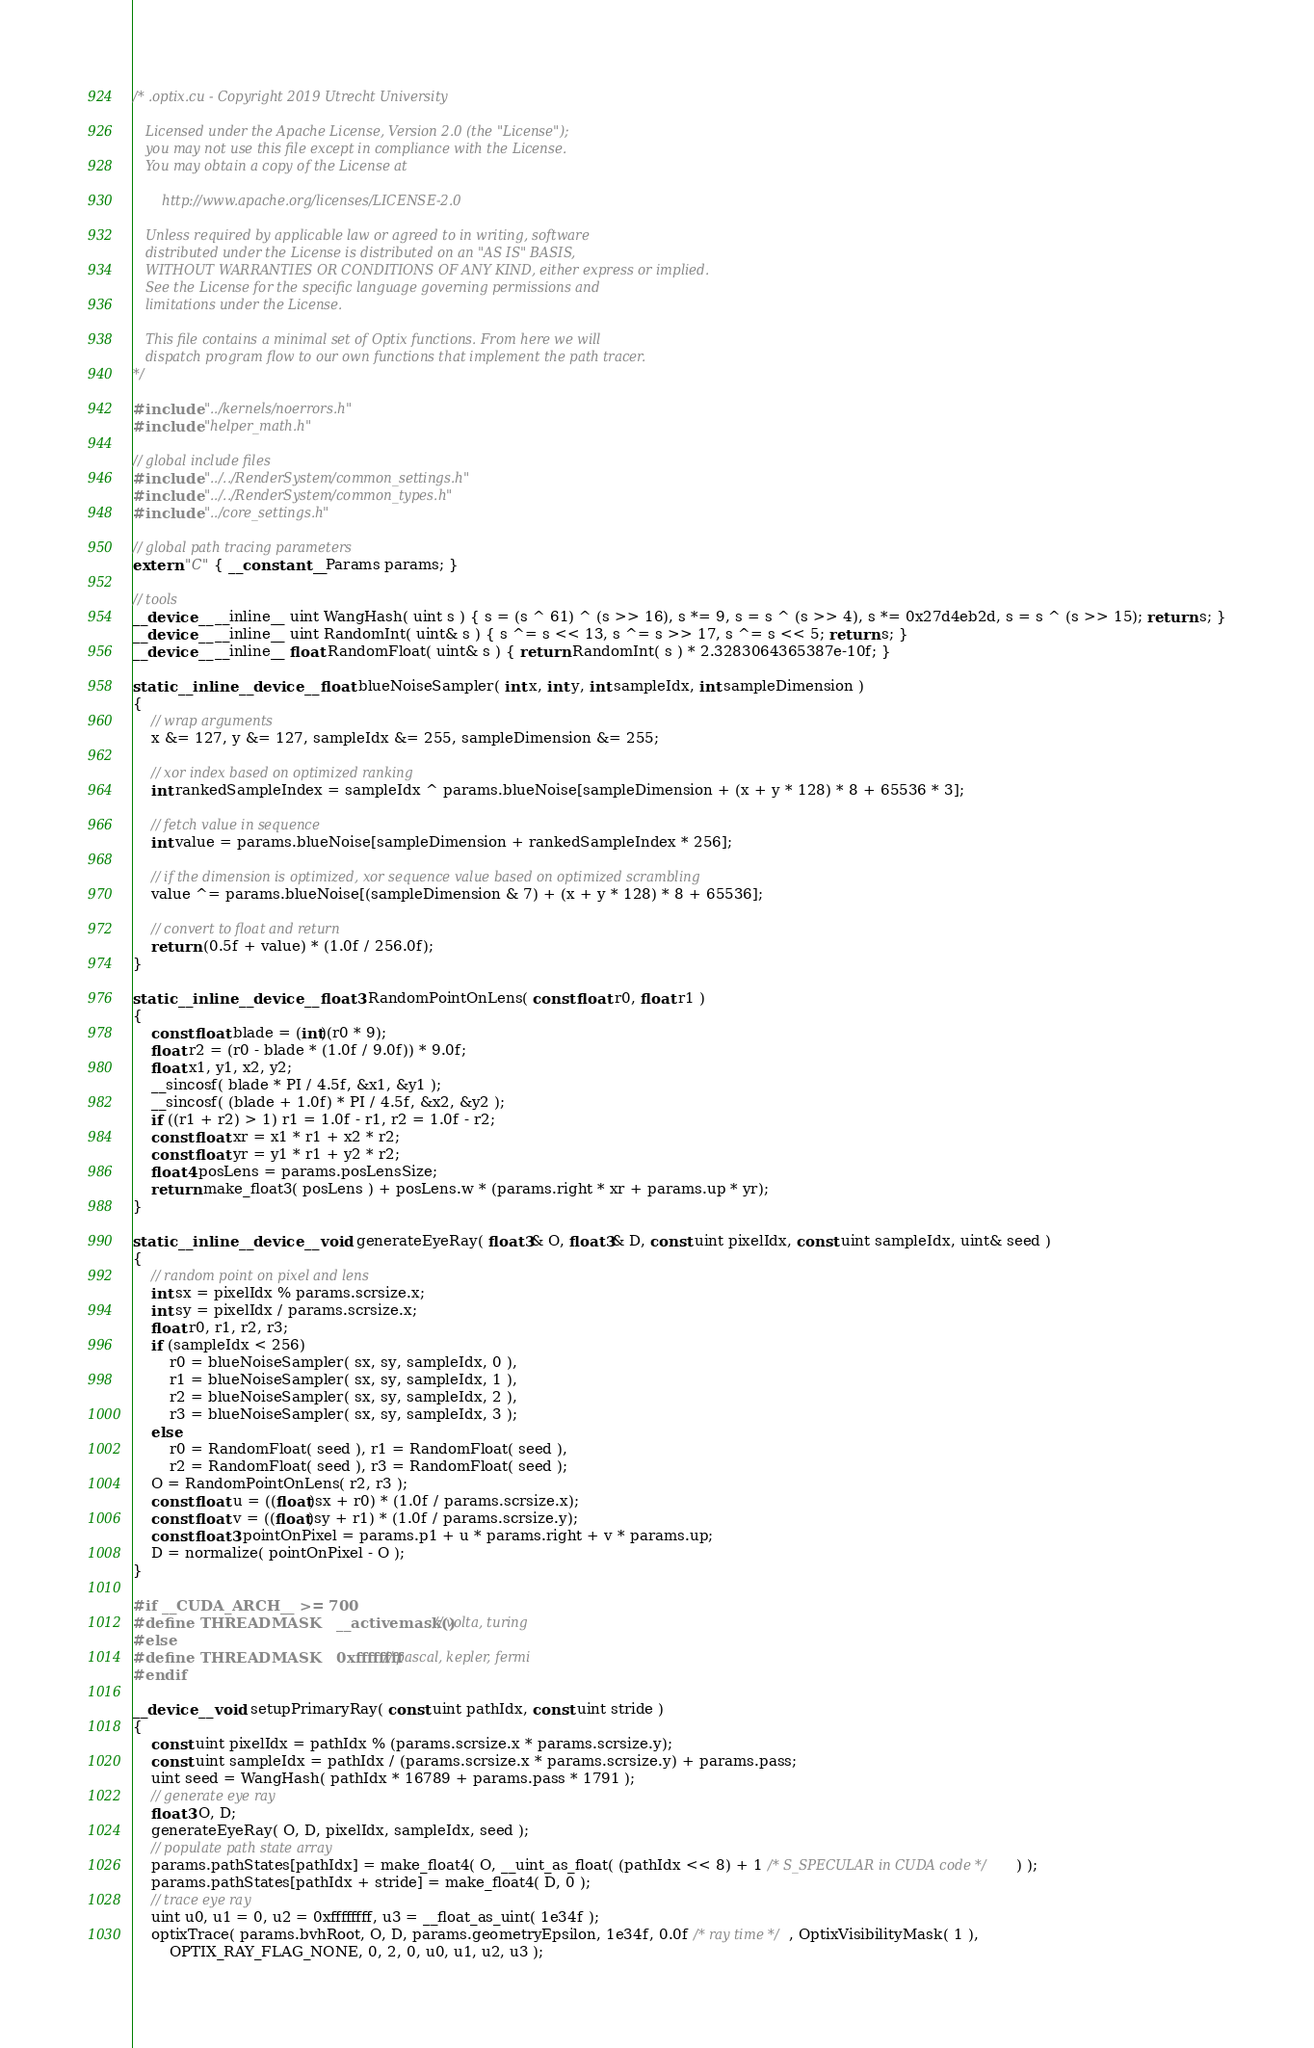Convert code to text. <code><loc_0><loc_0><loc_500><loc_500><_Cuda_>/* .optix.cu - Copyright 2019 Utrecht University

   Licensed under the Apache License, Version 2.0 (the "License");
   you may not use this file except in compliance with the License.
   You may obtain a copy of the License at

	   http://www.apache.org/licenses/LICENSE-2.0

   Unless required by applicable law or agreed to in writing, software
   distributed under the License is distributed on an "AS IS" BASIS,
   WITHOUT WARRANTIES OR CONDITIONS OF ANY KIND, either express or implied.
   See the License for the specific language governing permissions and
   limitations under the License.

   This file contains a minimal set of Optix functions. From here we will
   dispatch program flow to our own functions that implement the path tracer.
*/

#include "../kernels/noerrors.h"
#include "helper_math.h"

// global include files
#include "../../RenderSystem/common_settings.h"
#include "../../RenderSystem/common_types.h"
#include "../core_settings.h"

// global path tracing parameters
extern "C" { __constant__ Params params; }

// tools
__device__ __inline__ uint WangHash( uint s ) { s = (s ^ 61) ^ (s >> 16), s *= 9, s = s ^ (s >> 4), s *= 0x27d4eb2d, s = s ^ (s >> 15); return s; }
__device__ __inline__ uint RandomInt( uint& s ) { s ^= s << 13, s ^= s >> 17, s ^= s << 5; return s; }
__device__ __inline__ float RandomFloat( uint& s ) { return RandomInt( s ) * 2.3283064365387e-10f; }

static __inline __device__ float blueNoiseSampler( int x, int y, int sampleIdx, int sampleDimension )
{
	// wrap arguments
	x &= 127, y &= 127, sampleIdx &= 255, sampleDimension &= 255;

	// xor index based on optimized ranking
	int rankedSampleIndex = sampleIdx ^ params.blueNoise[sampleDimension + (x + y * 128) * 8 + 65536 * 3];

	// fetch value in sequence
	int value = params.blueNoise[sampleDimension + rankedSampleIndex * 256];

	// if the dimension is optimized, xor sequence value based on optimized scrambling
	value ^= params.blueNoise[(sampleDimension & 7) + (x + y * 128) * 8 + 65536];

	// convert to float and return
	return (0.5f + value) * (1.0f / 256.0f);
}

static __inline __device__ float3 RandomPointOnLens( const float r0, float r1 )
{
	const float blade = (int)(r0 * 9);
	float r2 = (r0 - blade * (1.0f / 9.0f)) * 9.0f;
	float x1, y1, x2, y2;
	__sincosf( blade * PI / 4.5f, &x1, &y1 );
	__sincosf( (blade + 1.0f) * PI / 4.5f, &x2, &y2 );
	if ((r1 + r2) > 1) r1 = 1.0f - r1, r2 = 1.0f - r2;
	const float xr = x1 * r1 + x2 * r2;
	const float yr = y1 * r1 + y2 * r2;
	float4 posLens = params.posLensSize;
	return make_float3( posLens ) + posLens.w * (params.right * xr + params.up * yr);
}

static __inline __device__ void generateEyeRay( float3& O, float3& D, const uint pixelIdx, const uint sampleIdx, uint& seed )
{
	// random point on pixel and lens
	int sx = pixelIdx % params.scrsize.x;
	int sy = pixelIdx / params.scrsize.x;
	float r0, r1, r2, r3;
	if (sampleIdx < 256)
		r0 = blueNoiseSampler( sx, sy, sampleIdx, 0 ),
		r1 = blueNoiseSampler( sx, sy, sampleIdx, 1 ),
		r2 = blueNoiseSampler( sx, sy, sampleIdx, 2 ),
		r3 = blueNoiseSampler( sx, sy, sampleIdx, 3 );
	else
		r0 = RandomFloat( seed ), r1 = RandomFloat( seed ),
		r2 = RandomFloat( seed ), r3 = RandomFloat( seed );
	O = RandomPointOnLens( r2, r3 );
	const float u = ((float)sx + r0) * (1.0f / params.scrsize.x);
	const float v = ((float)sy + r1) * (1.0f / params.scrsize.y);
	const float3 pointOnPixel = params.p1 + u * params.right + v * params.up;
	D = normalize( pointOnPixel - O );
}

#if __CUDA_ARCH__ >= 700
#define THREADMASK	__activemask() // volta, turing
#else
#define THREADMASK	0xffffffff // pascal, kepler, fermi
#endif

__device__ void setupPrimaryRay( const uint pathIdx, const uint stride )
{
	const uint pixelIdx = pathIdx % (params.scrsize.x * params.scrsize.y);
	const uint sampleIdx = pathIdx / (params.scrsize.x * params.scrsize.y) + params.pass;
	uint seed = WangHash( pathIdx * 16789 + params.pass * 1791 );
	// generate eye ray
	float3 O, D;
	generateEyeRay( O, D, pixelIdx, sampleIdx, seed );
	// populate path state array
	params.pathStates[pathIdx] = make_float4( O, __uint_as_float( (pathIdx << 8) + 1 /* S_SPECULAR in CUDA code */ ) );
	params.pathStates[pathIdx + stride] = make_float4( D, 0 );
	// trace eye ray
	uint u0, u1 = 0, u2 = 0xffffffff, u3 = __float_as_uint( 1e34f );
	optixTrace( params.bvhRoot, O, D, params.geometryEpsilon, 1e34f, 0.0f /* ray time */, OptixVisibilityMask( 1 ),
		OPTIX_RAY_FLAG_NONE, 0, 2, 0, u0, u1, u2, u3 );</code> 